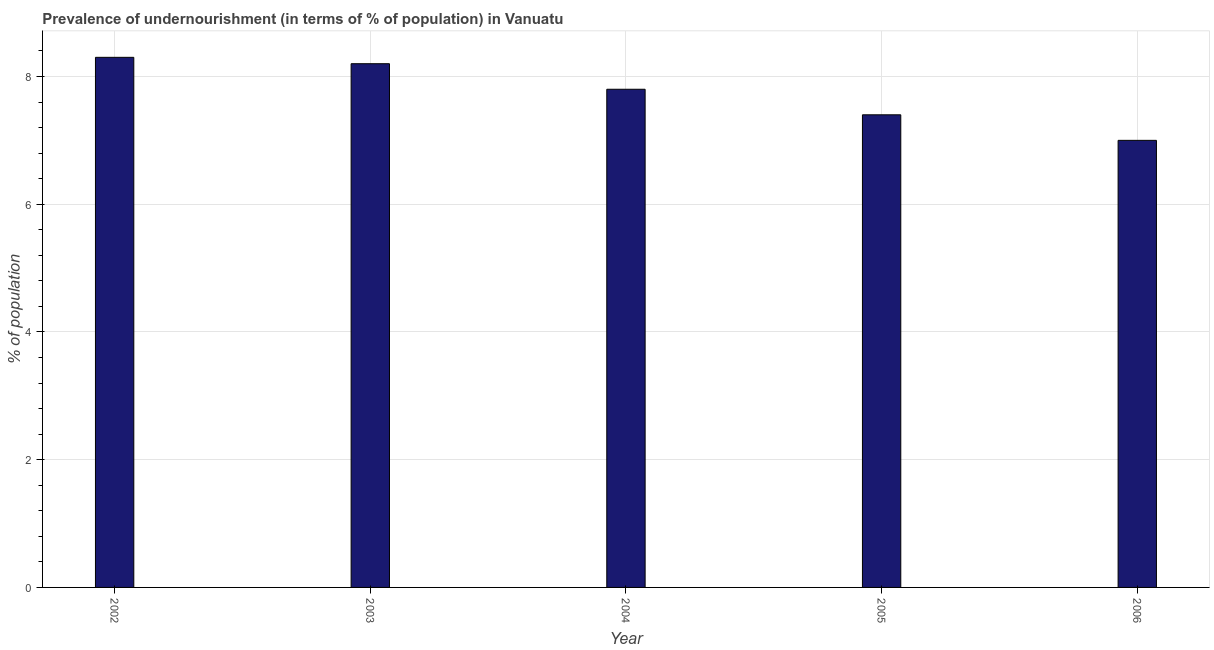What is the title of the graph?
Make the answer very short. Prevalence of undernourishment (in terms of % of population) in Vanuatu. What is the label or title of the Y-axis?
Your answer should be compact. % of population. What is the percentage of undernourished population in 2005?
Provide a short and direct response. 7.4. Across all years, what is the maximum percentage of undernourished population?
Make the answer very short. 8.3. Across all years, what is the minimum percentage of undernourished population?
Your answer should be compact. 7. In which year was the percentage of undernourished population minimum?
Make the answer very short. 2006. What is the sum of the percentage of undernourished population?
Offer a very short reply. 38.7. What is the average percentage of undernourished population per year?
Make the answer very short. 7.74. What is the ratio of the percentage of undernourished population in 2003 to that in 2006?
Your answer should be very brief. 1.17. Is the difference between the percentage of undernourished population in 2004 and 2005 greater than the difference between any two years?
Your answer should be very brief. No. What is the difference between the highest and the second highest percentage of undernourished population?
Ensure brevity in your answer.  0.1. Is the sum of the percentage of undernourished population in 2002 and 2005 greater than the maximum percentage of undernourished population across all years?
Offer a terse response. Yes. What is the difference between the highest and the lowest percentage of undernourished population?
Ensure brevity in your answer.  1.3. In how many years, is the percentage of undernourished population greater than the average percentage of undernourished population taken over all years?
Provide a short and direct response. 3. How many bars are there?
Offer a terse response. 5. How many years are there in the graph?
Provide a succinct answer. 5. Are the values on the major ticks of Y-axis written in scientific E-notation?
Your answer should be compact. No. What is the % of population in 2002?
Keep it short and to the point. 8.3. What is the % of population of 2005?
Provide a succinct answer. 7.4. What is the difference between the % of population in 2002 and 2004?
Your answer should be compact. 0.5. What is the difference between the % of population in 2002 and 2005?
Your response must be concise. 0.9. What is the difference between the % of population in 2003 and 2004?
Your response must be concise. 0.4. What is the difference between the % of population in 2003 and 2006?
Your answer should be very brief. 1.2. What is the difference between the % of population in 2004 and 2005?
Your answer should be very brief. 0.4. What is the difference between the % of population in 2004 and 2006?
Give a very brief answer. 0.8. What is the difference between the % of population in 2005 and 2006?
Make the answer very short. 0.4. What is the ratio of the % of population in 2002 to that in 2004?
Your answer should be very brief. 1.06. What is the ratio of the % of population in 2002 to that in 2005?
Give a very brief answer. 1.12. What is the ratio of the % of population in 2002 to that in 2006?
Your response must be concise. 1.19. What is the ratio of the % of population in 2003 to that in 2004?
Your response must be concise. 1.05. What is the ratio of the % of population in 2003 to that in 2005?
Offer a very short reply. 1.11. What is the ratio of the % of population in 2003 to that in 2006?
Provide a succinct answer. 1.17. What is the ratio of the % of population in 2004 to that in 2005?
Your answer should be very brief. 1.05. What is the ratio of the % of population in 2004 to that in 2006?
Keep it short and to the point. 1.11. What is the ratio of the % of population in 2005 to that in 2006?
Keep it short and to the point. 1.06. 